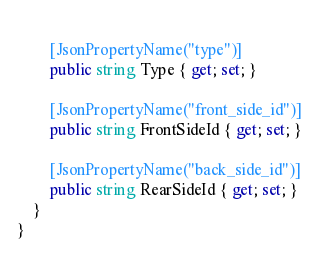Convert code to text. <code><loc_0><loc_0><loc_500><loc_500><_C#_>        
        [JsonPropertyName("type")]
        public string Type { get; set; }
        
        [JsonPropertyName("front_side_id")]
        public string FrontSideId { get; set; }
        
        [JsonPropertyName("back_side_id")]
        public string RearSideId { get; set; }
    }
}</code> 